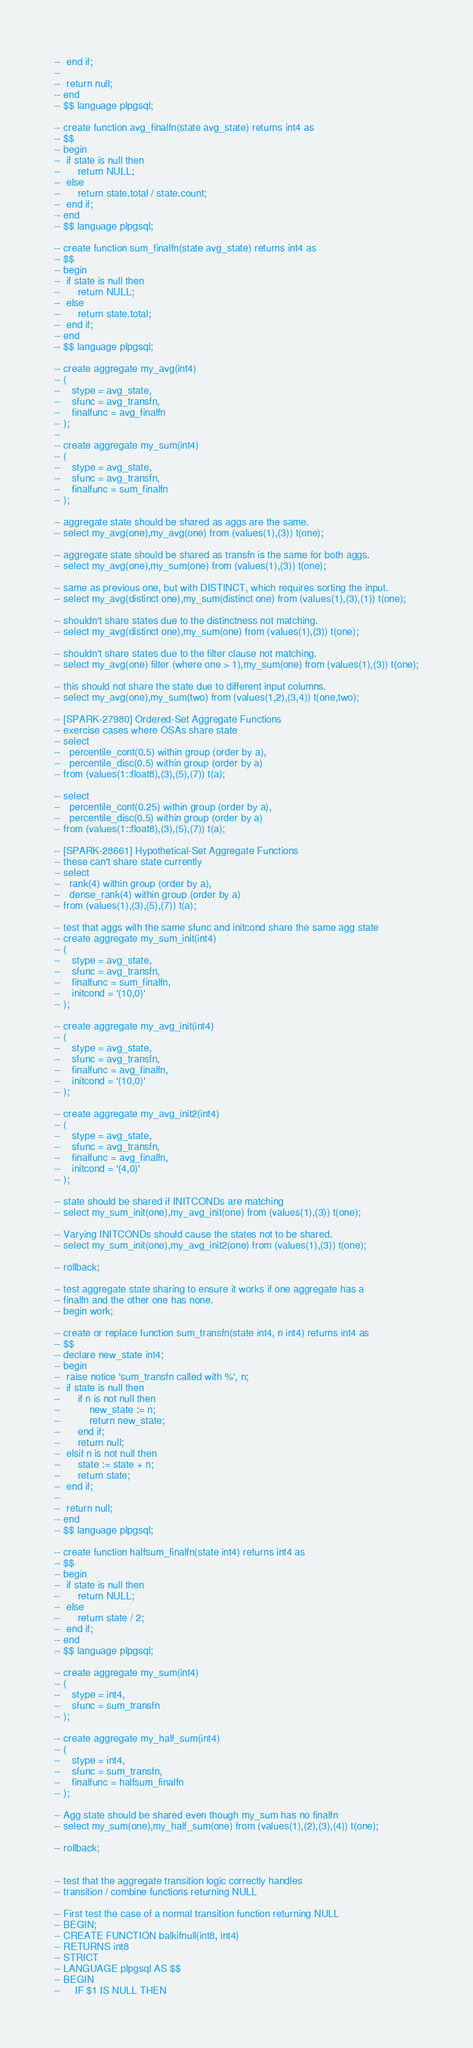<code> <loc_0><loc_0><loc_500><loc_500><_SQL_>-- 	end if;
--
-- 	return null;
-- end
-- $$ language plpgsql;

-- create function avg_finalfn(state avg_state) returns int4 as
-- $$
-- begin
-- 	if state is null then
-- 		return NULL;
-- 	else
-- 		return state.total / state.count;
-- 	end if;
-- end
-- $$ language plpgsql;

-- create function sum_finalfn(state avg_state) returns int4 as
-- $$
-- begin
-- 	if state is null then
-- 		return NULL;
-- 	else
-- 		return state.total;
-- 	end if;
-- end
-- $$ language plpgsql;

-- create aggregate my_avg(int4)
-- (
--    stype = avg_state,
--    sfunc = avg_transfn,
--    finalfunc = avg_finalfn
-- );
--
-- create aggregate my_sum(int4)
-- (
--    stype = avg_state,
--    sfunc = avg_transfn,
--    finalfunc = sum_finalfn
-- );

-- aggregate state should be shared as aggs are the same.
-- select my_avg(one),my_avg(one) from (values(1),(3)) t(one);

-- aggregate state should be shared as transfn is the same for both aggs.
-- select my_avg(one),my_sum(one) from (values(1),(3)) t(one);

-- same as previous one, but with DISTINCT, which requires sorting the input.
-- select my_avg(distinct one),my_sum(distinct one) from (values(1),(3),(1)) t(one);

-- shouldn't share states due to the distinctness not matching.
-- select my_avg(distinct one),my_sum(one) from (values(1),(3)) t(one);

-- shouldn't share states due to the filter clause not matching.
-- select my_avg(one) filter (where one > 1),my_sum(one) from (values(1),(3)) t(one);

-- this should not share the state due to different input columns.
-- select my_avg(one),my_sum(two) from (values(1,2),(3,4)) t(one,two);

-- [SPARK-27980] Ordered-Set Aggregate Functions
-- exercise cases where OSAs share state
-- select
--   percentile_cont(0.5) within group (order by a),
--   percentile_disc(0.5) within group (order by a)
-- from (values(1::float8),(3),(5),(7)) t(a);

-- select
--   percentile_cont(0.25) within group (order by a),
--   percentile_disc(0.5) within group (order by a)
-- from (values(1::float8),(3),(5),(7)) t(a);

-- [SPARK-28661] Hypothetical-Set Aggregate Functions
-- these can't share state currently
-- select
--   rank(4) within group (order by a),
--   dense_rank(4) within group (order by a)
-- from (values(1),(3),(5),(7)) t(a);

-- test that aggs with the same sfunc and initcond share the same agg state
-- create aggregate my_sum_init(int4)
-- (
--    stype = avg_state,
--    sfunc = avg_transfn,
--    finalfunc = sum_finalfn,
--    initcond = '(10,0)'
-- );

-- create aggregate my_avg_init(int4)
-- (
--    stype = avg_state,
--    sfunc = avg_transfn,
--    finalfunc = avg_finalfn,
--    initcond = '(10,0)'
-- );

-- create aggregate my_avg_init2(int4)
-- (
--    stype = avg_state,
--    sfunc = avg_transfn,
--    finalfunc = avg_finalfn,
--    initcond = '(4,0)'
-- );

-- state should be shared if INITCONDs are matching
-- select my_sum_init(one),my_avg_init(one) from (values(1),(3)) t(one);

-- Varying INITCONDs should cause the states not to be shared.
-- select my_sum_init(one),my_avg_init2(one) from (values(1),(3)) t(one);

-- rollback;

-- test aggregate state sharing to ensure it works if one aggregate has a
-- finalfn and the other one has none.
-- begin work;

-- create or replace function sum_transfn(state int4, n int4) returns int4 as
-- $$
-- declare new_state int4;
-- begin
-- 	raise notice 'sum_transfn called with %', n;
-- 	if state is null then
-- 		if n is not null then
-- 			new_state := n;
-- 			return new_state;
-- 		end if;
-- 		return null;
-- 	elsif n is not null then
-- 		state := state + n;
-- 		return state;
-- 	end if;
--
-- 	return null;
-- end
-- $$ language plpgsql;

-- create function halfsum_finalfn(state int4) returns int4 as
-- $$
-- begin
-- 	if state is null then
-- 		return NULL;
-- 	else
-- 		return state / 2;
-- 	end if;
-- end
-- $$ language plpgsql;

-- create aggregate my_sum(int4)
-- (
--    stype = int4,
--    sfunc = sum_transfn
-- );

-- create aggregate my_half_sum(int4)
-- (
--    stype = int4,
--    sfunc = sum_transfn,
--    finalfunc = halfsum_finalfn
-- );

-- Agg state should be shared even though my_sum has no finalfn
-- select my_sum(one),my_half_sum(one) from (values(1),(2),(3),(4)) t(one);

-- rollback;


-- test that the aggregate transition logic correctly handles
-- transition / combine functions returning NULL

-- First test the case of a normal transition function returning NULL
-- BEGIN;
-- CREATE FUNCTION balkifnull(int8, int4)
-- RETURNS int8
-- STRICT
-- LANGUAGE plpgsql AS $$
-- BEGIN
--     IF $1 IS NULL THEN</code> 